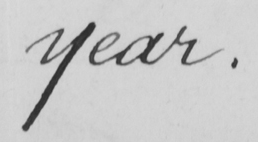Transcribe the text shown in this historical manuscript line. year . 